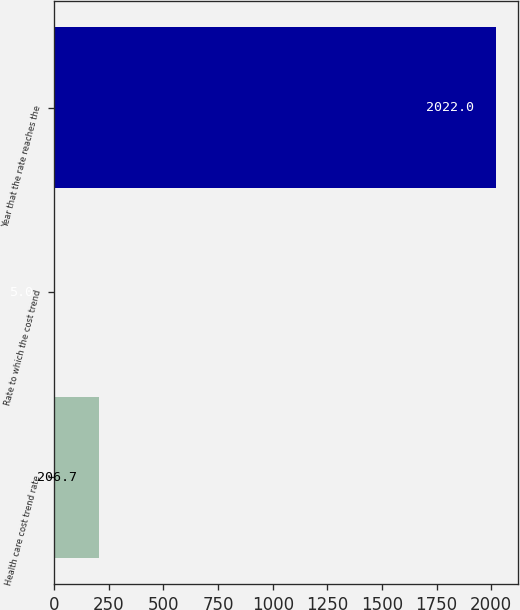Convert chart. <chart><loc_0><loc_0><loc_500><loc_500><bar_chart><fcel>Health care cost trend rate<fcel>Rate to which the cost trend<fcel>Year that the rate reaches the<nl><fcel>206.7<fcel>5<fcel>2022<nl></chart> 